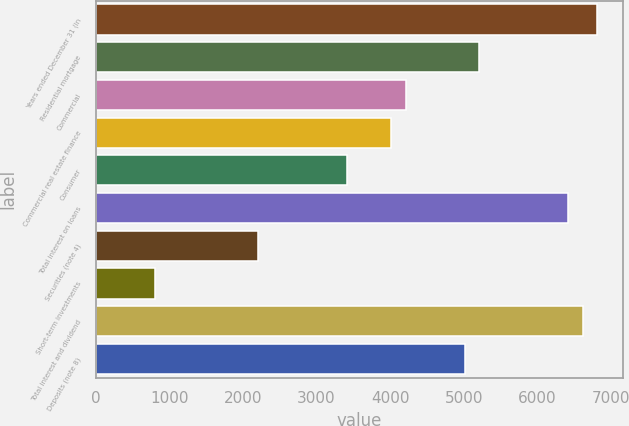Convert chart to OTSL. <chart><loc_0><loc_0><loc_500><loc_500><bar_chart><fcel>Years ended December 31 (in<fcel>Residential mortgage<fcel>Commercial<fcel>Commercial real estate finance<fcel>Consumer<fcel>Total interest on loans<fcel>Securities (note 4)<fcel>Short-term investments<fcel>Total interest and dividend<fcel>Deposits (note 8)<nl><fcel>6815.6<fcel>5212.4<fcel>4210.4<fcel>4010<fcel>3408.8<fcel>6414.8<fcel>2206.4<fcel>803.6<fcel>6615.2<fcel>5012<nl></chart> 